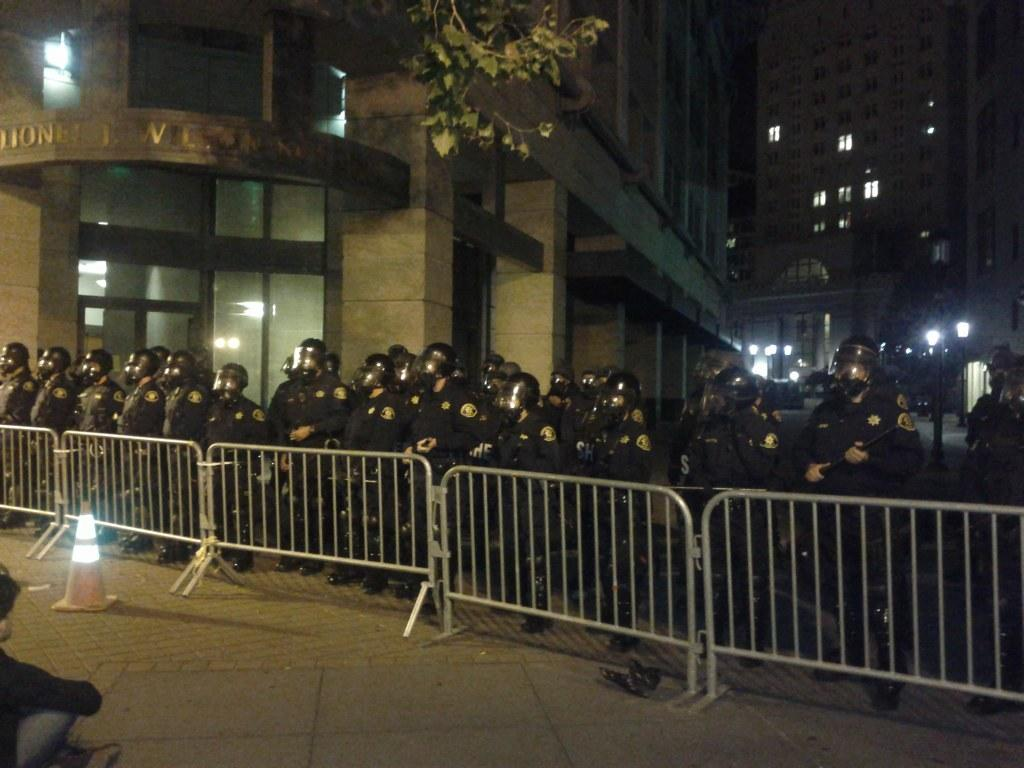How many people are in the image? There is a group of people in the image, but the exact number is not specified. What can be seen in the image besides the people? There is a fence, a traffic cone, poles, lights, leaves, and buildings in the background of the image. What might be used to control traffic in the image? The traffic cone is present in the image, which is often used to control traffic. What type of vegetation is visible in the image? Leaves are visible in the image, which suggests the presence of trees or plants. What is visible in the background of the image? There are buildings in the background of the image. How many bikes are being operated by the people in the image? There is no mention of bikes in the image, so it is not possible to determine how many are being operated. 